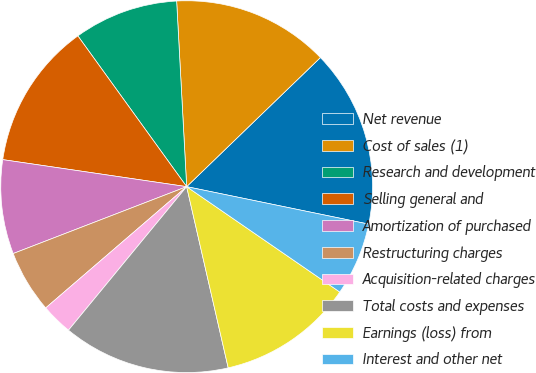Convert chart to OTSL. <chart><loc_0><loc_0><loc_500><loc_500><pie_chart><fcel>Net revenue<fcel>Cost of sales (1)<fcel>Research and development<fcel>Selling general and<fcel>Amortization of purchased<fcel>Restructuring charges<fcel>Acquisition-related charges<fcel>Total costs and expenses<fcel>Earnings (loss) from<fcel>Interest and other net<nl><fcel>15.45%<fcel>13.64%<fcel>9.09%<fcel>12.73%<fcel>8.18%<fcel>5.45%<fcel>2.73%<fcel>14.55%<fcel>11.82%<fcel>6.36%<nl></chart> 